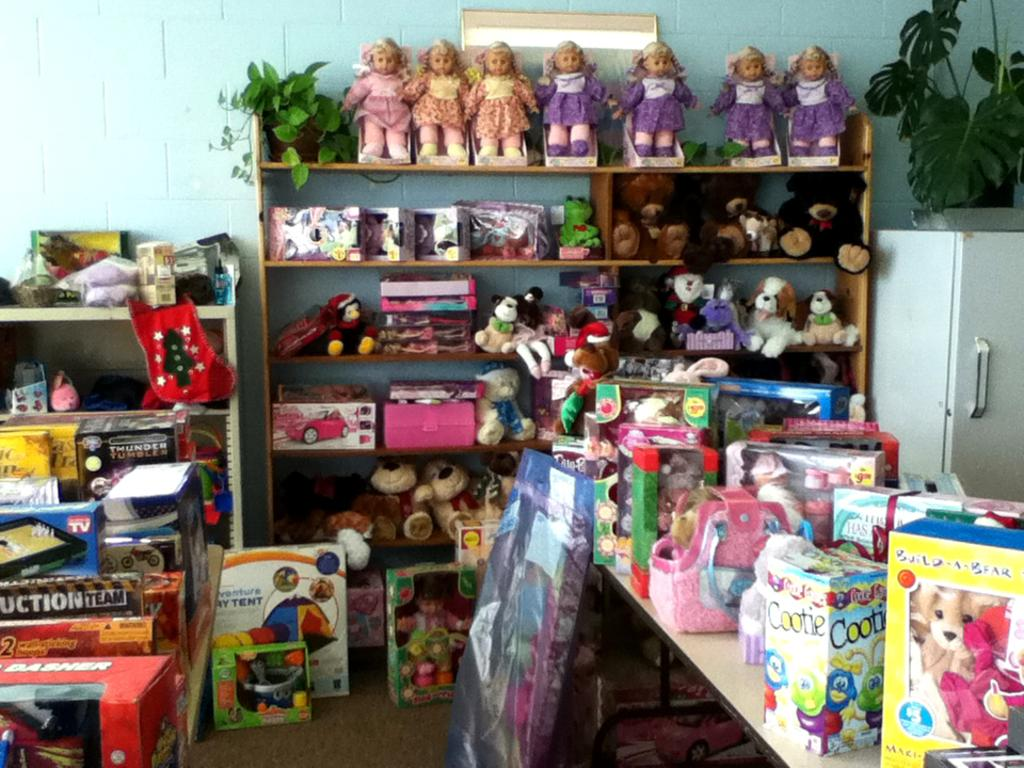<image>
Provide a brief description of the given image. A counter top with many items on it including a Build A Bear in a box. 